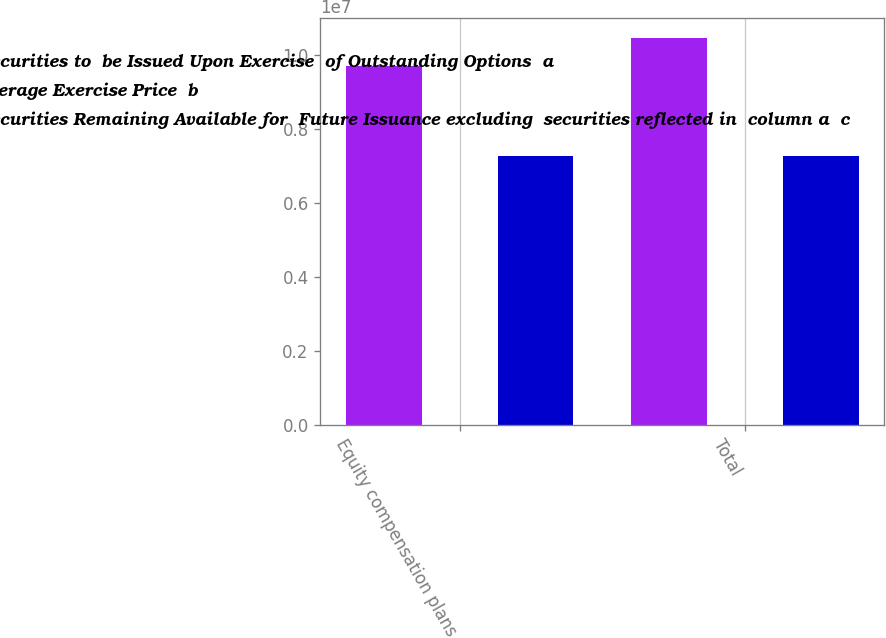Convert chart to OTSL. <chart><loc_0><loc_0><loc_500><loc_500><stacked_bar_chart><ecel><fcel>Equity compensation plans<fcel>Total<nl><fcel>Number of Securities to  be Issued Upon Exercise  of Outstanding Options  a<fcel>9.68306e+06<fcel>1.04594e+07<nl><fcel>Weighted  Average Exercise Price  b<fcel>78.07<fcel>75.46<nl><fcel>Number of Securities Remaining Available for  Future Issuance excluding  securities reflected in  column a  c<fcel>7.26956e+06<fcel>7.26956e+06<nl></chart> 